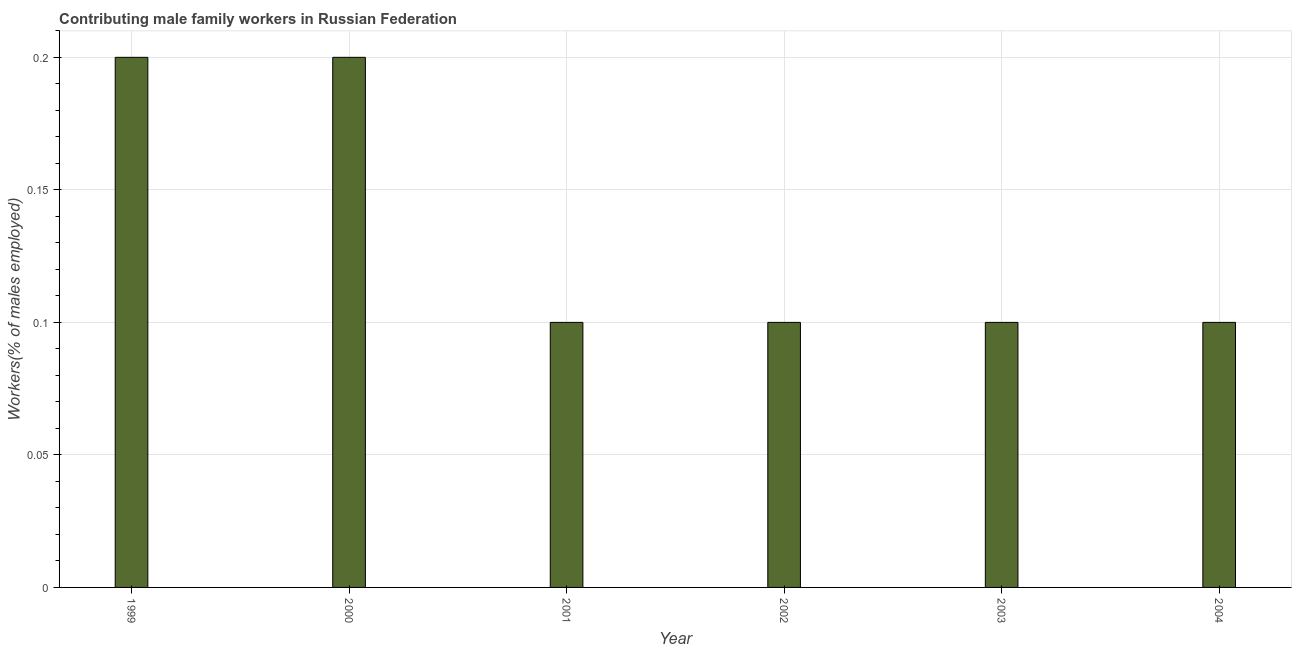What is the title of the graph?
Keep it short and to the point. Contributing male family workers in Russian Federation. What is the label or title of the X-axis?
Your response must be concise. Year. What is the label or title of the Y-axis?
Offer a terse response. Workers(% of males employed). What is the contributing male family workers in 2000?
Ensure brevity in your answer.  0.2. Across all years, what is the maximum contributing male family workers?
Your answer should be very brief. 0.2. Across all years, what is the minimum contributing male family workers?
Make the answer very short. 0.1. What is the sum of the contributing male family workers?
Offer a terse response. 0.8. What is the average contributing male family workers per year?
Your answer should be very brief. 0.13. What is the median contributing male family workers?
Offer a terse response. 0.1. In how many years, is the contributing male family workers greater than 0.18 %?
Provide a succinct answer. 2. Do a majority of the years between 2002 and 2003 (inclusive) have contributing male family workers greater than 0.2 %?
Keep it short and to the point. No. What is the ratio of the contributing male family workers in 1999 to that in 2003?
Your response must be concise. 2. What is the difference between the highest and the second highest contributing male family workers?
Keep it short and to the point. 0. Is the sum of the contributing male family workers in 2000 and 2003 greater than the maximum contributing male family workers across all years?
Make the answer very short. Yes. What is the difference between the highest and the lowest contributing male family workers?
Give a very brief answer. 0.1. Are all the bars in the graph horizontal?
Provide a short and direct response. No. How many years are there in the graph?
Make the answer very short. 6. What is the Workers(% of males employed) in 1999?
Provide a succinct answer. 0.2. What is the Workers(% of males employed) of 2000?
Make the answer very short. 0.2. What is the Workers(% of males employed) in 2001?
Offer a terse response. 0.1. What is the Workers(% of males employed) of 2002?
Provide a succinct answer. 0.1. What is the Workers(% of males employed) of 2003?
Ensure brevity in your answer.  0.1. What is the Workers(% of males employed) of 2004?
Provide a succinct answer. 0.1. What is the difference between the Workers(% of males employed) in 1999 and 2001?
Provide a succinct answer. 0.1. What is the difference between the Workers(% of males employed) in 2000 and 2001?
Your answer should be very brief. 0.1. What is the difference between the Workers(% of males employed) in 2000 and 2002?
Offer a terse response. 0.1. What is the difference between the Workers(% of males employed) in 2001 and 2003?
Ensure brevity in your answer.  0. What is the difference between the Workers(% of males employed) in 2002 and 2003?
Your response must be concise. 0. What is the difference between the Workers(% of males employed) in 2003 and 2004?
Keep it short and to the point. 0. What is the ratio of the Workers(% of males employed) in 1999 to that in 2002?
Your response must be concise. 2. What is the ratio of the Workers(% of males employed) in 2000 to that in 2001?
Your answer should be compact. 2. What is the ratio of the Workers(% of males employed) in 2000 to that in 2003?
Your answer should be compact. 2. What is the ratio of the Workers(% of males employed) in 2000 to that in 2004?
Ensure brevity in your answer.  2. What is the ratio of the Workers(% of males employed) in 2001 to that in 2002?
Your answer should be compact. 1. What is the ratio of the Workers(% of males employed) in 2001 to that in 2003?
Ensure brevity in your answer.  1. What is the ratio of the Workers(% of males employed) in 2001 to that in 2004?
Make the answer very short. 1. What is the ratio of the Workers(% of males employed) in 2003 to that in 2004?
Your answer should be very brief. 1. 